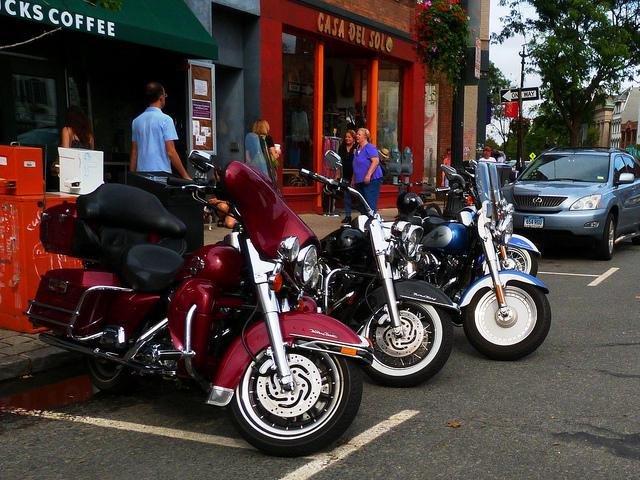What is the parent organization of the SUV?

Choices:
A) ford
B) toyota
C) honda
D) ferrari toyota 